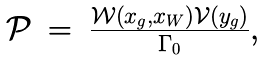Convert formula to latex. <formula><loc_0><loc_0><loc_500><loc_500>\begin{array} { l c l } \mathcal { P } & = & \frac { \mathcal { W } \left ( x _ { g } , x _ { W } \right ) \mathcal { V } \left ( y _ { g } \right ) } { \Gamma _ { 0 } } , \end{array}</formula> 